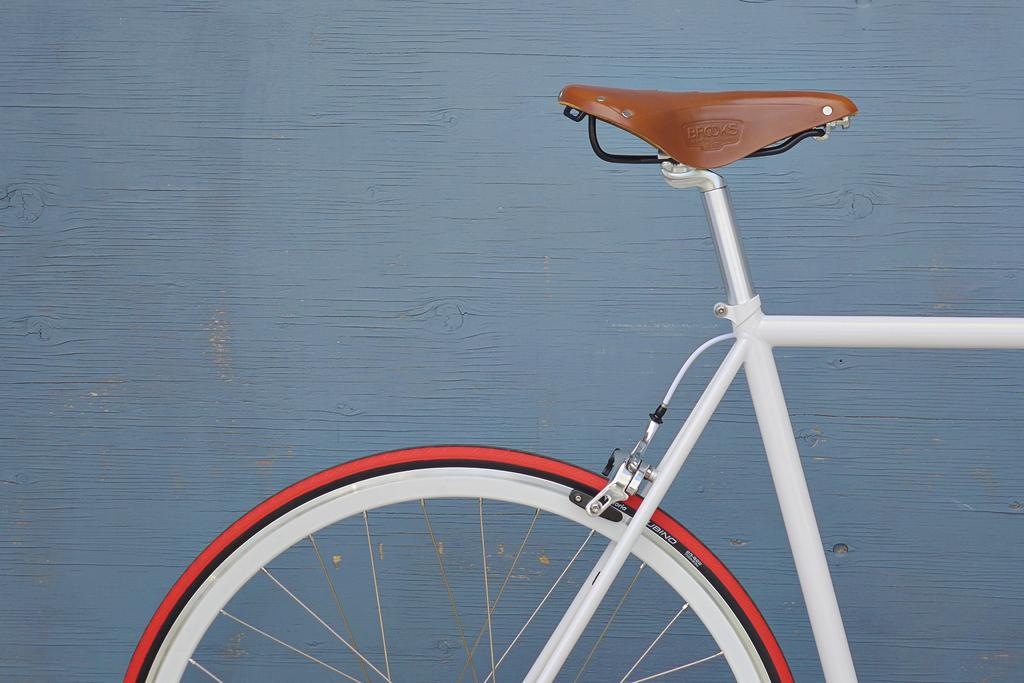What is the main object in the image? There is a bicycle in the image. Where is the bicycle located in relation to the image? The bicycle is in the front of the image. What can be seen in the background of the image? There is a wall in the background of the image. How many oranges are hanging from the bicycle in the image? There are no oranges present in the image, as it only features a bicycle and a wall in the background. 